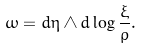<formula> <loc_0><loc_0><loc_500><loc_500>\omega = d \eta \wedge d \log \frac { \xi } { \rho } .</formula> 